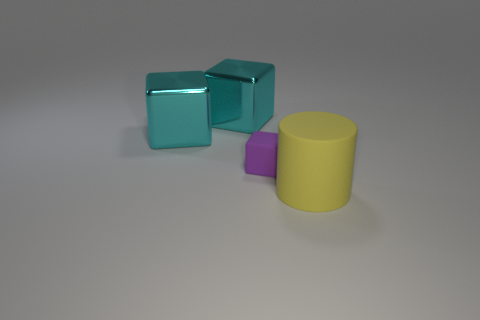Is there anything that suggests the size of these objects? While the image itself doesn't provide explicit points of reference to ascertain the precise size of the objects, the word 'tiny' used to describe the purple object implies that it is relatively small within this context. The shadows and perspective could suggest that these are not large items in a real-world setting. 